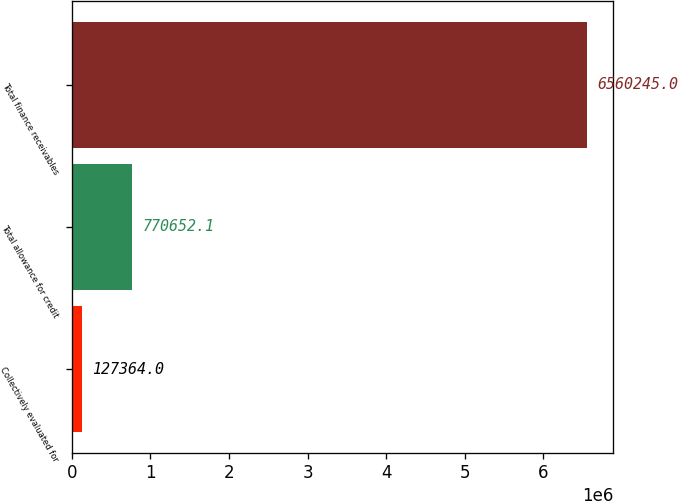<chart> <loc_0><loc_0><loc_500><loc_500><bar_chart><fcel>Collectively evaluated for<fcel>Total allowance for credit<fcel>Total finance receivables<nl><fcel>127364<fcel>770652<fcel>6.56024e+06<nl></chart> 